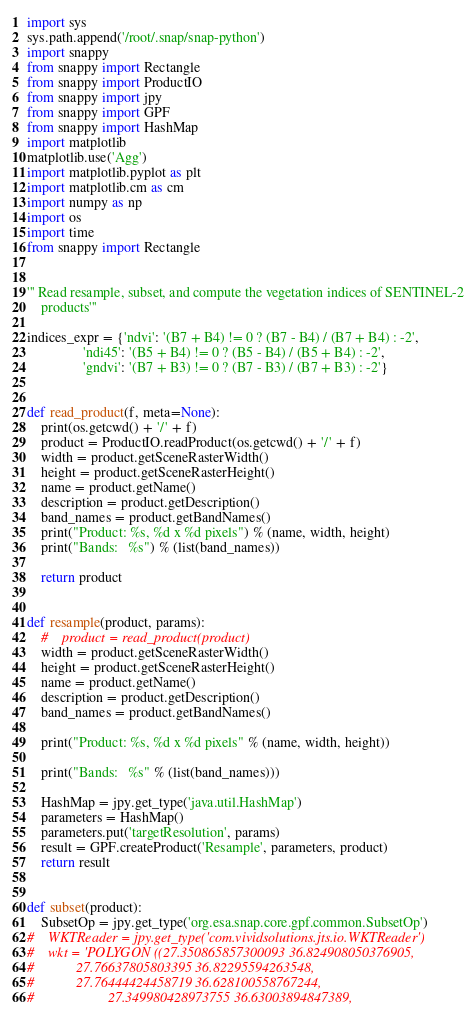Convert code to text. <code><loc_0><loc_0><loc_500><loc_500><_Python_>import sys
sys.path.append('/root/.snap/snap-python')
import snappy
from snappy import Rectangle
from snappy import ProductIO
from snappy import jpy
from snappy import GPF
from snappy import HashMap
import matplotlib
matplotlib.use('Agg')
import matplotlib.pyplot as plt
import matplotlib.cm as cm
import numpy as np
import os
import time
from snappy import Rectangle


''' Read resample, subset, and compute the vegetation indices of SENTINEL-2
    products'''

indices_expr = {'ndvi': '(B7 + B4) != 0 ? (B7 - B4) / (B7 + B4) : -2',
                'ndi45': '(B5 + B4) != 0 ? (B5 - B4) / (B5 + B4) : -2',
                'gndvi': '(B7 + B3) != 0 ? (B7 - B3) / (B7 + B3) : -2'}


def read_product(f, meta=None):
    print(os.getcwd() + '/' + f)
    product = ProductIO.readProduct(os.getcwd() + '/' + f)
    width = product.getSceneRasterWidth()
    height = product.getSceneRasterHeight()
    name = product.getName()
    description = product.getDescription()
    band_names = product.getBandNames()
    print("Product: %s, %d x %d pixels") % (name, width, height)
    print("Bands:   %s") % (list(band_names))

    return product


def resample(product, params):
    #    product = read_product(product)
    width = product.getSceneRasterWidth()
    height = product.getSceneRasterHeight()
    name = product.getName()
    description = product.getDescription()
    band_names = product.getBandNames()

    print("Product: %s, %d x %d pixels" % (name, width, height))

    print("Bands:   %s" % (list(band_names)))

    HashMap = jpy.get_type('java.util.HashMap')
    parameters = HashMap()
    parameters.put('targetResolution', params)
    result = GPF.createProduct('Resample', parameters, product)
    return result


def subset(product):
    SubsetOp = jpy.get_type('org.esa.snap.core.gpf.common.SubsetOp')
#    WKTReader = jpy.get_type('com.vividsolutions.jts.io.WKTReader')
#    wkt = 'POLYGON ((27.350865857300093 36.824908050376905,
#		     27.76637805803395 36.82295594263548,
#	 	     27.76444424458719 36.628100558767244,
#                     27.349980428973755 36.63003894847389,</code> 